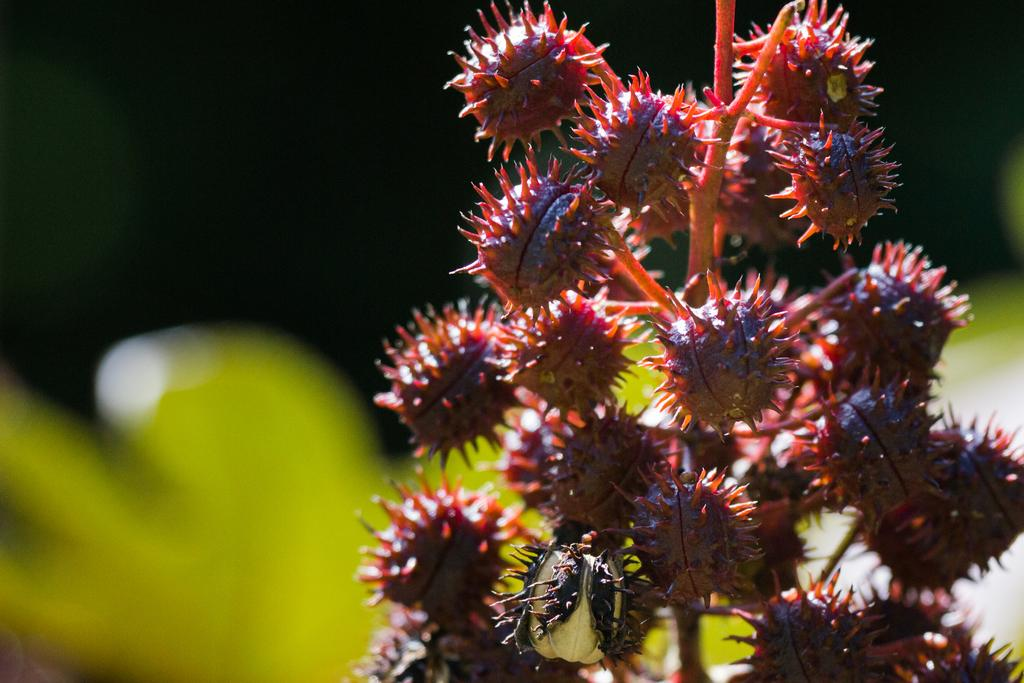What is present in the image? There is a plant in the image. What color is the plant? The plant is red in color. Can you describe the background of the image? The background of the image is blurred. What type of metal is used to create the scarecrow in the image? There is no scarecаreсrоw present in the image; it features a red plant with a blurred background. 